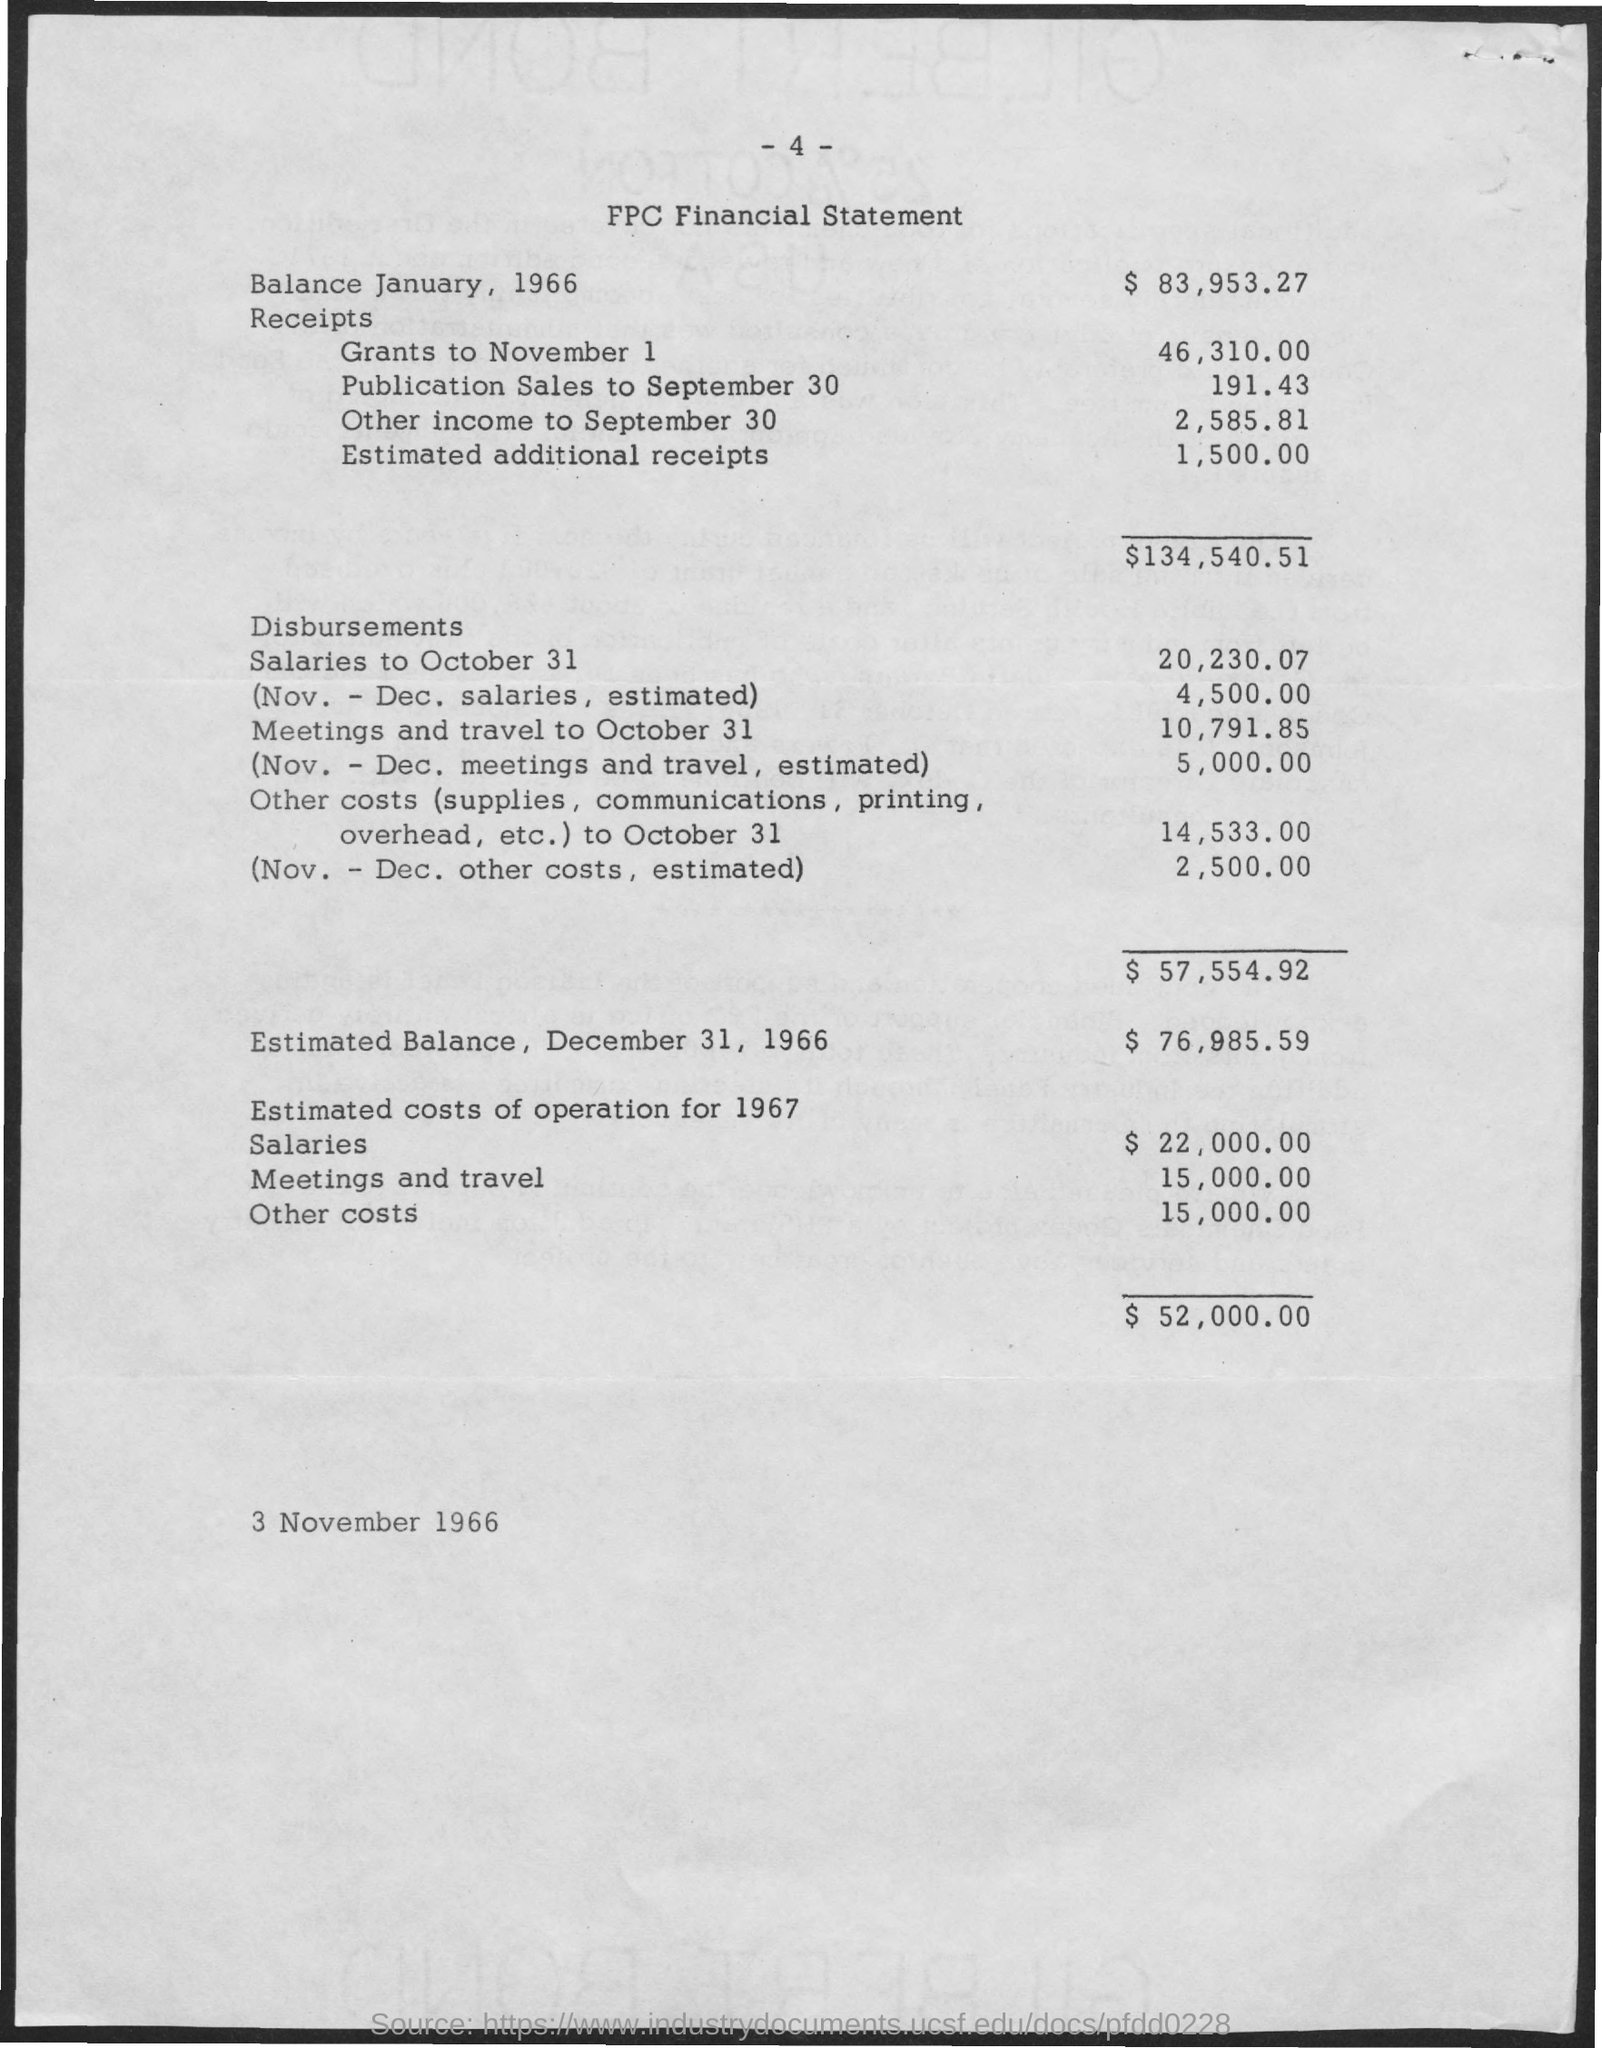What is the Title of the document?
Make the answer very short. FPC FINANCIAL STATEMENT. What is the "balance January, 1966"?
Your answer should be compact. $83, 953.27. How much is  'receipts' for 'grants to november' 1?
Your response must be concise. 46,310.00. What are the receipts for Publication sales to september 30?
Your response must be concise. 191 43. What are the receipts for other income to September 30?
Give a very brief answer. 2,585.81. What are the estimated additional receipts?
Your answer should be compact. 1,500. What are the total receipts?
Give a very brief answer. $134,540 51. What is the balance December 31,1966?
Give a very brief answer. $76,985.59. How much is the estimated costs of operation for 1966 for salaries?
Your answer should be compact. 22,000.00. What is the estimated costs of operation for 1966 for meetings and travel?
Ensure brevity in your answer.  15,000.00. 